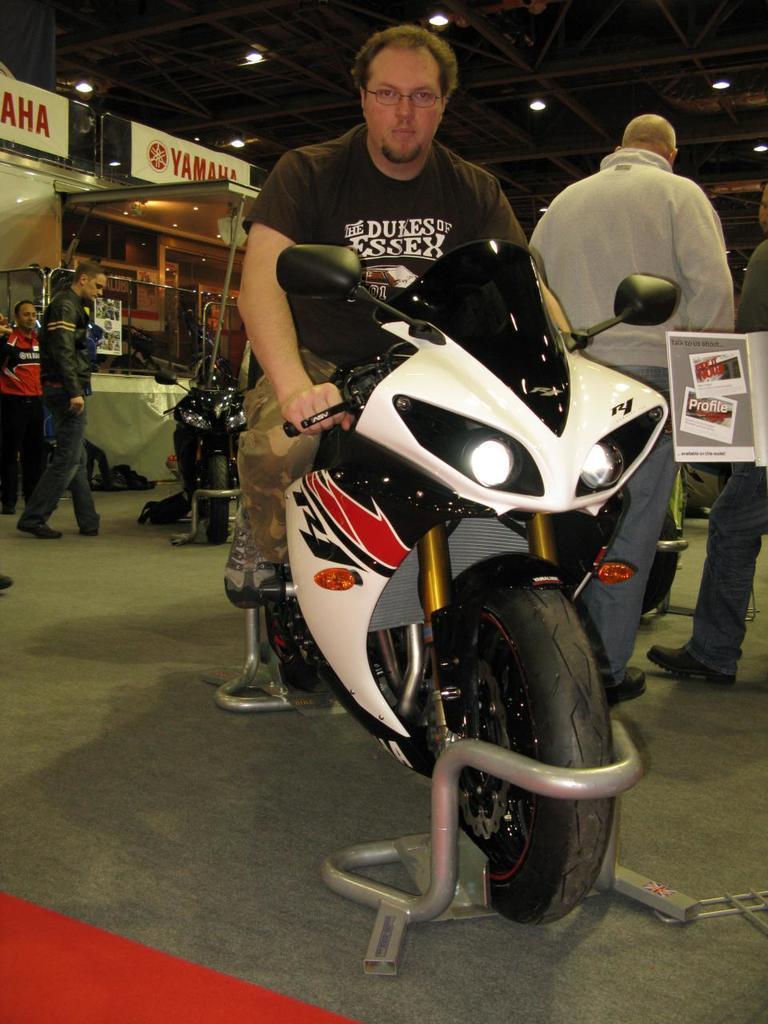How would you summarize this image in a sentence or two? In the center we can see one man sitting on the bike. In the background we can see few persons were standing and there is a wall,lights and few vehicles. 